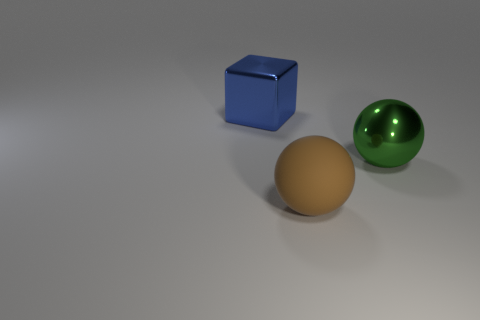How would you describe the lighting and shadows in the scene? The lighting in the scene is soft and diffused, coming from the upper left side, which creates gentle shadows to the right of the objects. These shadows help to give a sense of the three-dimensional form and placement of the objects on the surface. 